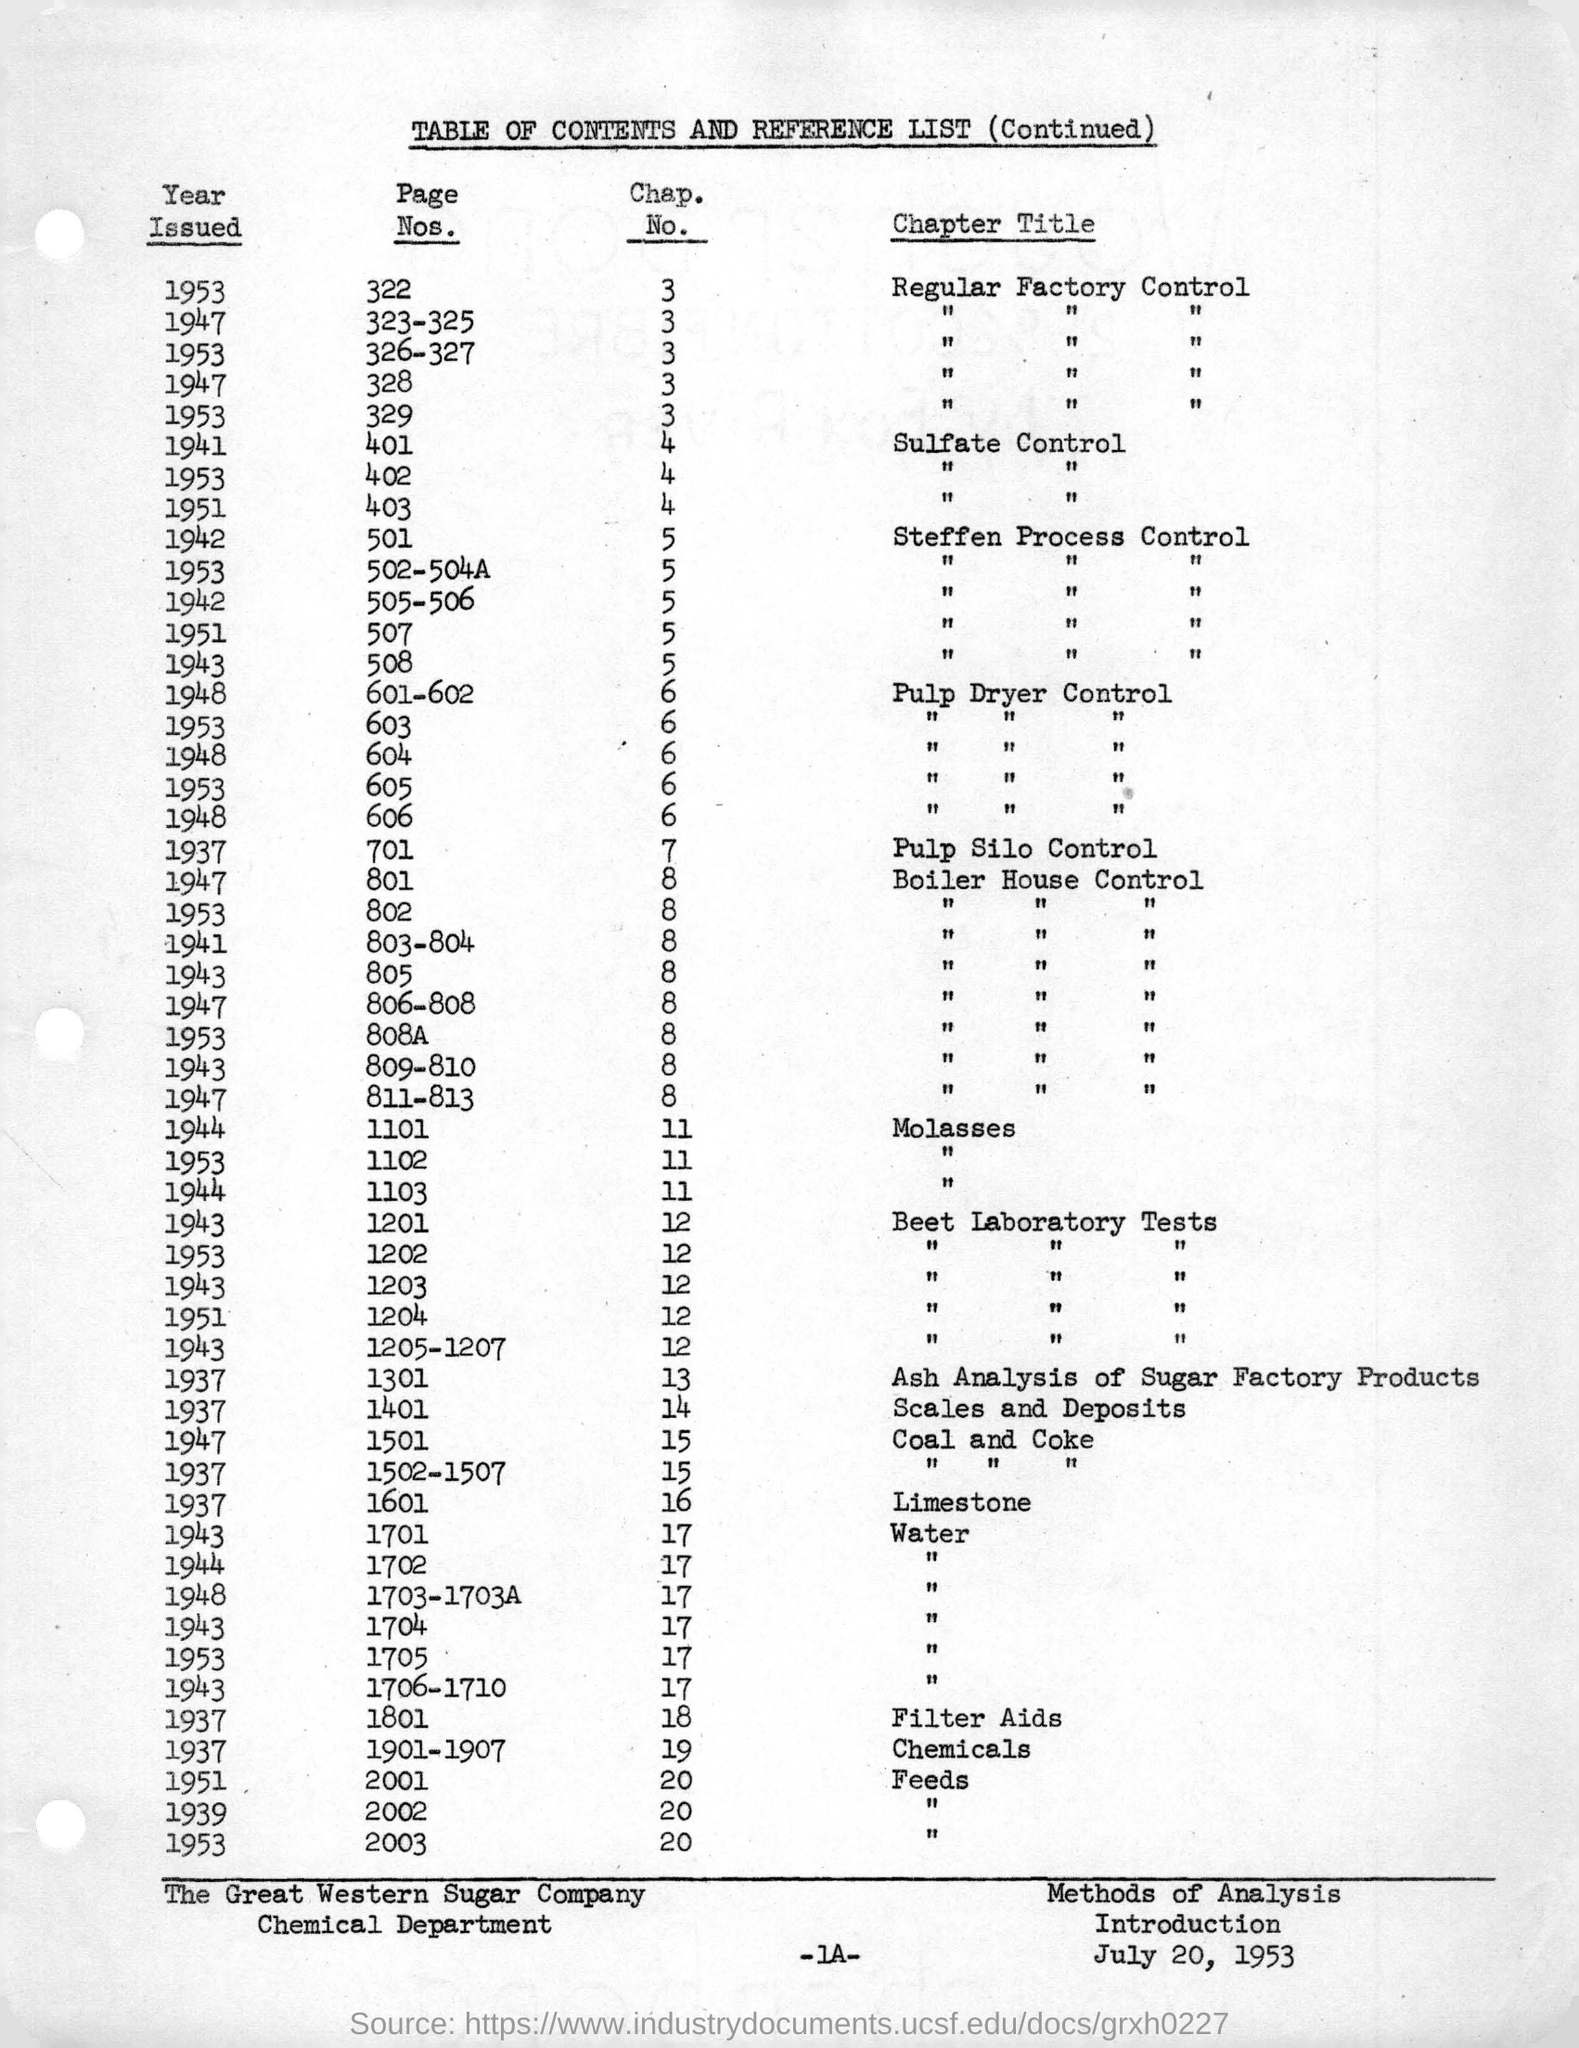Identify some key points in this picture. The date mentioned in the footer is July 20, 1953. The chapter of Filter Aids issued in 1937 is Chapter No. 18. The Pulpsil silo control was first issued in the year 1937. 